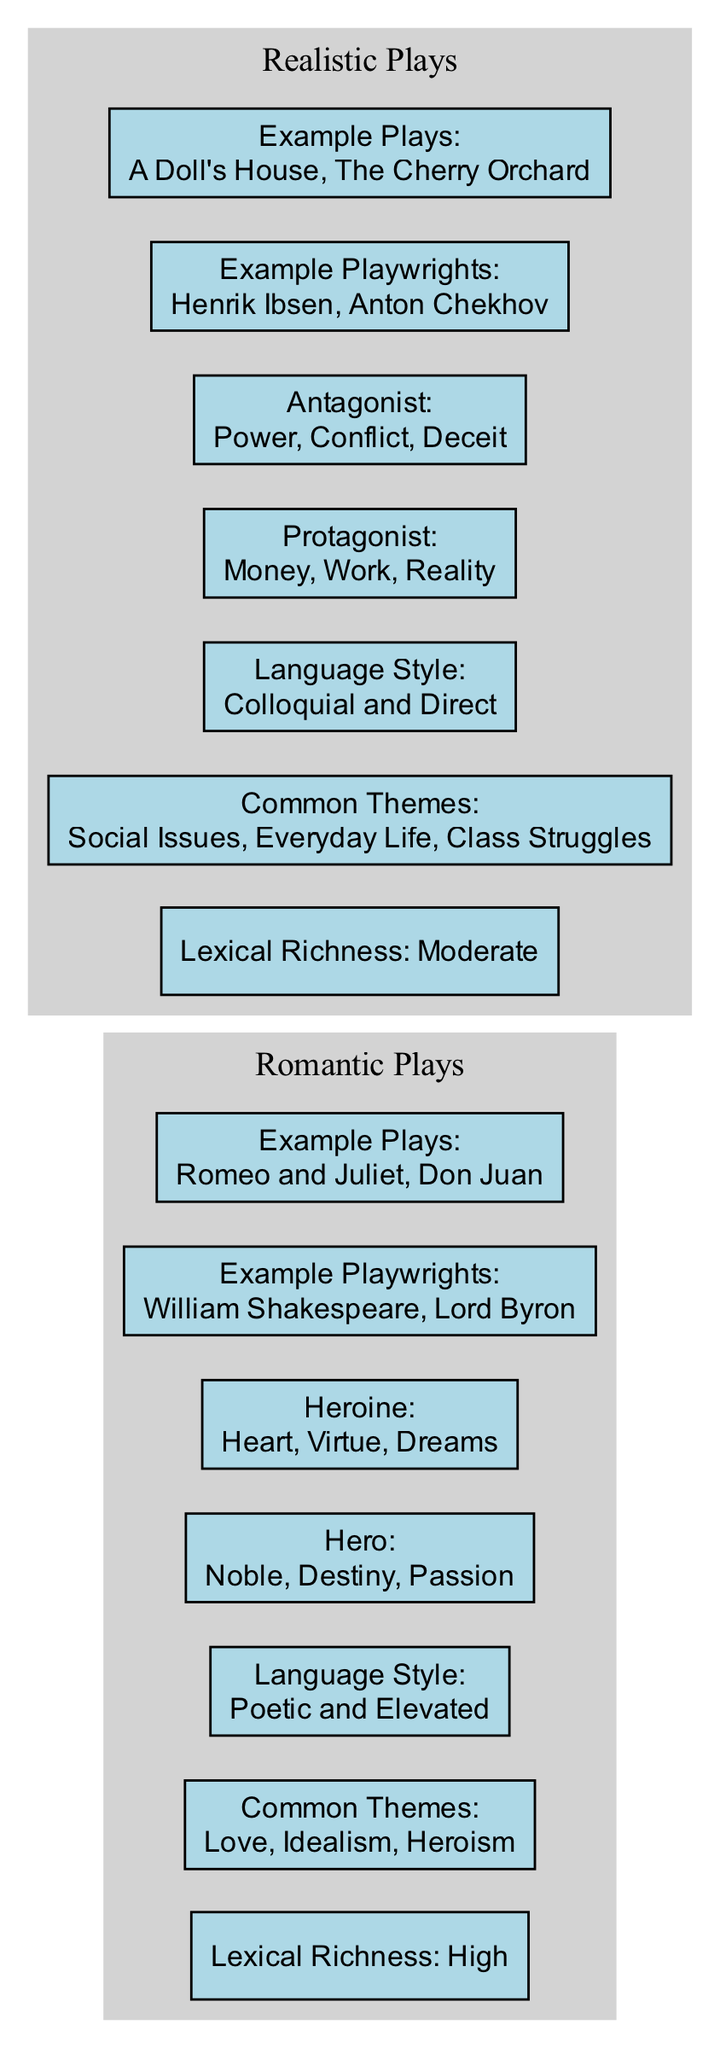What is the lexical richness of Romantic Plays? The diagram shows a specific attribute for Romantic Plays labeled as "Lexical Richness." Upon examining the node under Romantic Plays, it states "High," which indicates the level of lexical richness in this genre.
Answer: High What are the common themes in Realistic Plays? The "Common Themes" node under Realistic Plays lists the themes associated with this genre. Looking at that specific node, we see it includes "Social Issues," "Everyday Life," and "Class Struggles." Thus, these are the themes defined for Realistic Plays.
Answer: Social Issues, Everyday Life, Class Struggles Which character in Romantic Plays uses the common word "Destiny"? Under the "Character Dialogues" section for Romantic Plays, the Hero is listed with the common words he uses. The word "Destiny" is included among those, specifically associated with the Hero character.
Answer: Hero How many characters are associated with dialogues in Realistic Plays? The "Character Dialogues" section for Realistic Plays contains two character nodes: "Protagonist" and "Antagonist." Counting these nodes shows there are a total of two characters that comprise the dialogues in this section.
Answer: 2 Which playwright is an example of Romantic Plays? In the "Example Playwrights" node for Romantic Plays, the diagram lists "William Shakespeare" and "Lord Byron." Asking for an example of a playwright will lead to mentioning any of those listed. For a specific answer, we can simply state "William Shakespeare."
Answer: William Shakespeare What type of language style is associated with Realistic Plays? The "Language Style" node under Realistic Plays provides insight into the style of language that characterizes this genre. It states "Colloquial and Direct," which explicitly defines the type of language style used in Realistic Plays.
Answer: Colloquial and Direct Which common word is used by the Antagonist in Realistic Plays? The "Character Dialogues" for Realistic Plays showcases the Antagonist's common words, and among those words, we find "Power," "Conflict," and "Deceit." Asking for one specific common word will lead to the first one listed, which is "Power."
Answer: Power What is the lexical richness of Realistic Plays? The "Lexical Richness" node for Realistic Plays indicates its level labeled as "Moderate." This is a straightforward point of information presented in the diagram regarding this genre's lexical richness.
Answer: Moderate How many example plays are listed for Romantic Plays? In the "Example Plays" node of the Romantic Plays section, we can see that two example plays are given: "Romeo and Juliet" and "Don Juan." Therefore, by counting these listed plays, we determine their total.
Answer: 2 